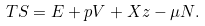<formula> <loc_0><loc_0><loc_500><loc_500>T S = E + p V + X z - \mu N .</formula> 